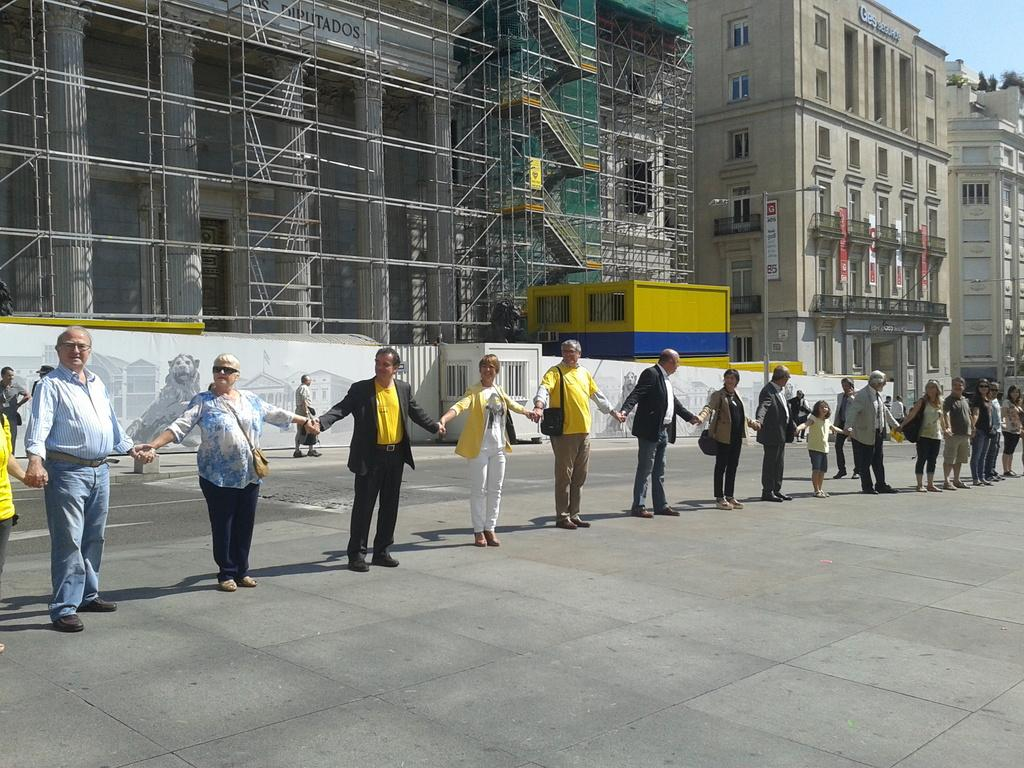What are the people in the image doing? The people in the image are standing in a queue. How are the people in the queue connected to each other? The people are holding each other's hands. What can be seen in the background of the image? There are buildings in the background of the image. What part of the sky is visible in the image? The sky is visible at the top right side of the image. What type of force can be seen pushing the people in the image? There is no force pushing the people in the image; they are standing in a queue and holding hands. At what angle are the people leaning in the image? The people in the image are not leaning at any specific angle; they are standing upright while holding hands. 